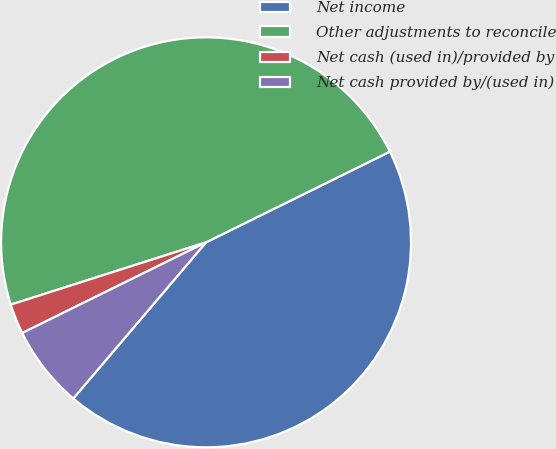Convert chart to OTSL. <chart><loc_0><loc_0><loc_500><loc_500><pie_chart><fcel>Net income<fcel>Other adjustments to reconcile<fcel>Net cash (used in)/provided by<fcel>Net cash provided by/(used in)<nl><fcel>43.51%<fcel>47.62%<fcel>2.38%<fcel>6.49%<nl></chart> 